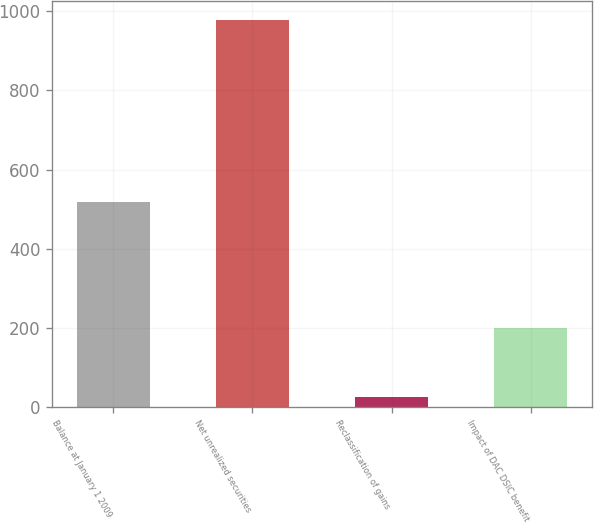Convert chart. <chart><loc_0><loc_0><loc_500><loc_500><bar_chart><fcel>Balance at January 1 2009<fcel>Net unrealized securities<fcel>Reclassification of gains<fcel>Impact of DAC DSIC benefit<nl><fcel>518<fcel>977<fcel>25<fcel>199<nl></chart> 